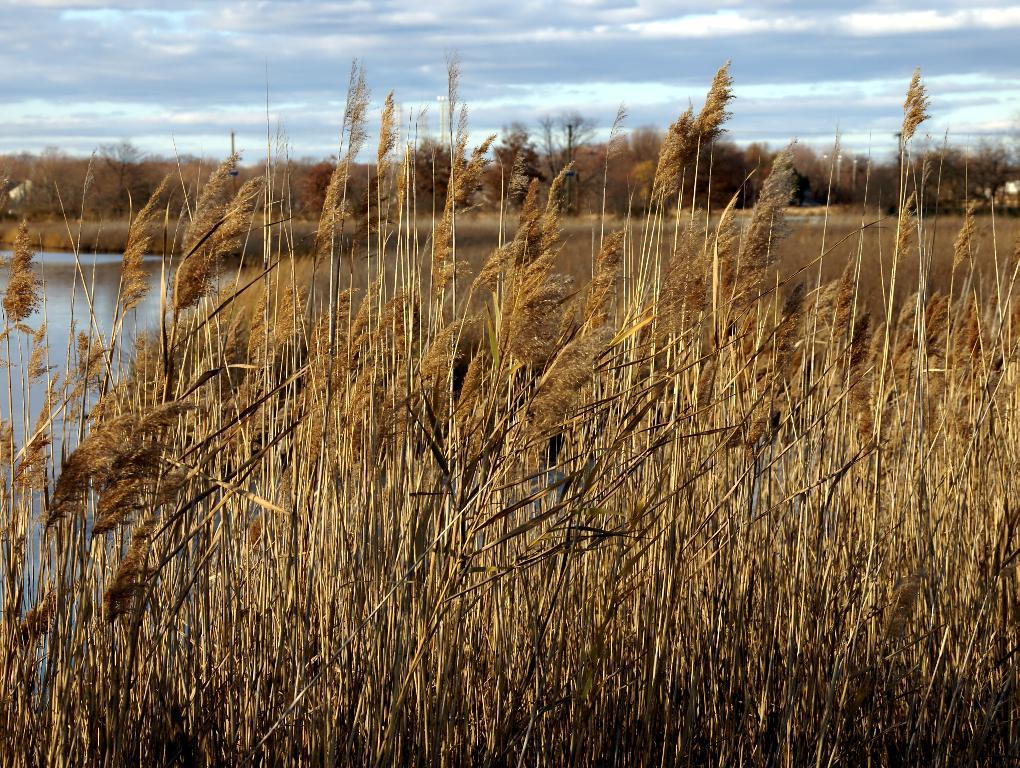What type of ground surface is visible in the image? There is grass on the ground in the image. What type of vegetation can be seen in the image? There are trees visible in the image. What natural element is visible in the image? There is water visible in the image. How would you describe the sky in the image? The sky is blue and cloudy in the image. Where is the basin located in the image? There is no basin present in the image. What type of party is being held in the image? There is no party depicted in the image. 